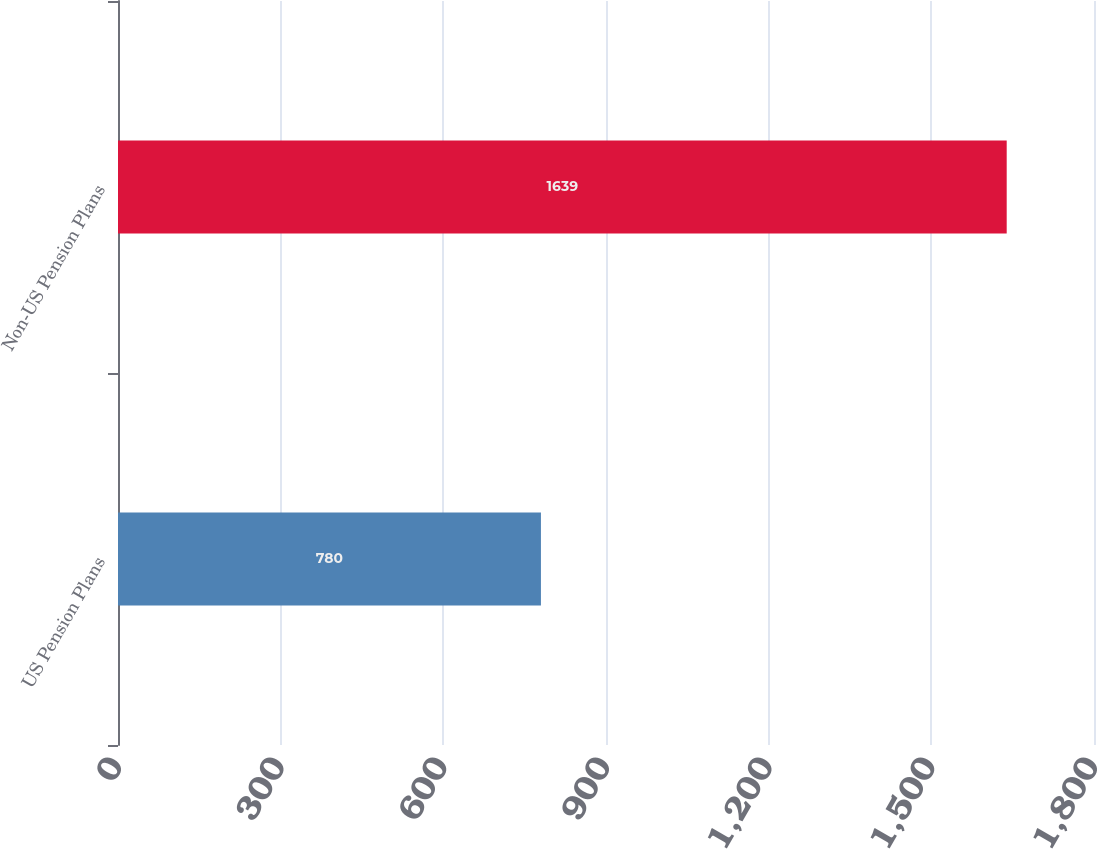<chart> <loc_0><loc_0><loc_500><loc_500><bar_chart><fcel>US Pension Plans<fcel>Non-US Pension Plans<nl><fcel>780<fcel>1639<nl></chart> 